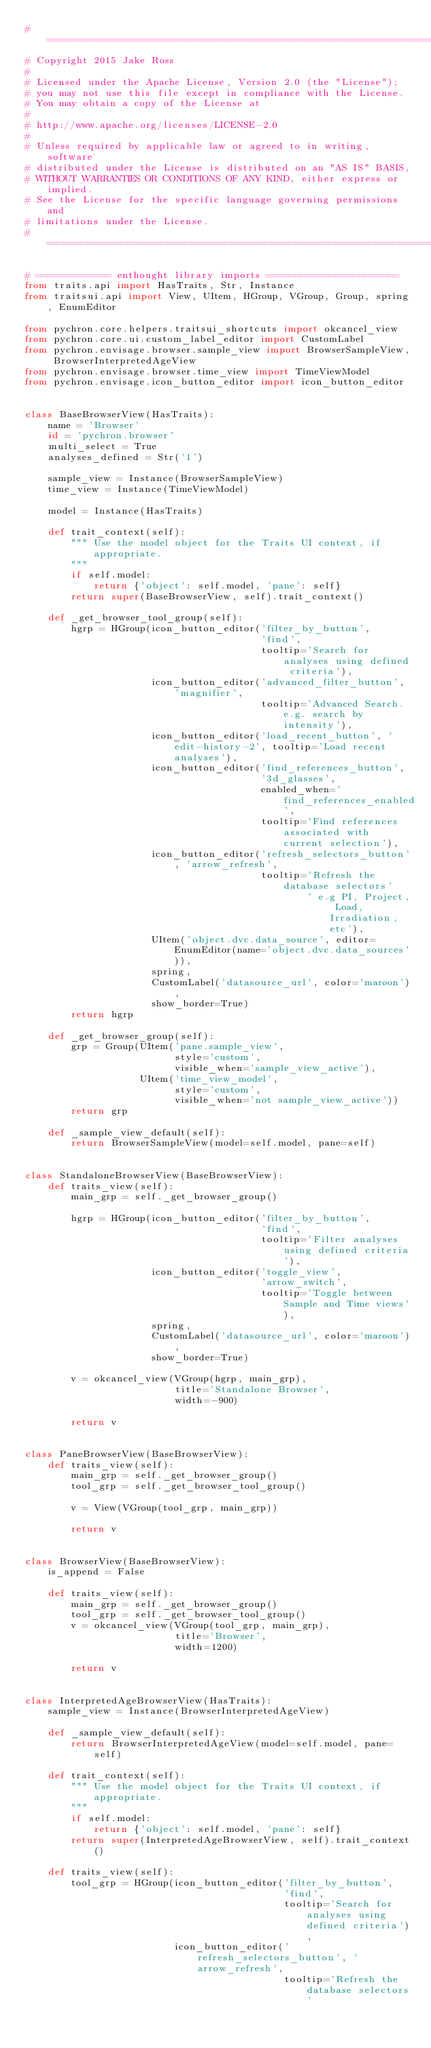<code> <loc_0><loc_0><loc_500><loc_500><_Python_># ===============================================================================
# Copyright 2015 Jake Ross
#
# Licensed under the Apache License, Version 2.0 (the "License");
# you may not use this file except in compliance with the License.
# You may obtain a copy of the License at
#
# http://www.apache.org/licenses/LICENSE-2.0
#
# Unless required by applicable law or agreed to in writing, software
# distributed under the License is distributed on an "AS IS" BASIS,
# WITHOUT WARRANTIES OR CONDITIONS OF ANY KIND, either express or implied.
# See the License for the specific language governing permissions and
# limitations under the License.
# ===============================================================================

# ============= enthought library imports =======================
from traits.api import HasTraits, Str, Instance
from traitsui.api import View, UItem, HGroup, VGroup, Group, spring, EnumEditor

from pychron.core.helpers.traitsui_shortcuts import okcancel_view
from pychron.core.ui.custom_label_editor import CustomLabel
from pychron.envisage.browser.sample_view import BrowserSampleView, BrowserInterpretedAgeView
from pychron.envisage.browser.time_view import TimeViewModel
from pychron.envisage.icon_button_editor import icon_button_editor


class BaseBrowserView(HasTraits):
    name = 'Browser'
    id = 'pychron.browser'
    multi_select = True
    analyses_defined = Str('1')

    sample_view = Instance(BrowserSampleView)
    time_view = Instance(TimeViewModel)

    model = Instance(HasTraits)

    def trait_context(self):
        """ Use the model object for the Traits UI context, if appropriate.
        """
        if self.model:
            return {'object': self.model, 'pane': self}
        return super(BaseBrowserView, self).trait_context()

    def _get_browser_tool_group(self):
        hgrp = HGroup(icon_button_editor('filter_by_button',
                                         'find',
                                         tooltip='Search for analyses using defined criteria'),
                      icon_button_editor('advanced_filter_button', 'magnifier',
                                         tooltip='Advanced Search. e.g. search by intensity'),
                      icon_button_editor('load_recent_button', 'edit-history-2', tooltip='Load recent analyses'),
                      icon_button_editor('find_references_button',
                                         '3d_glasses',
                                         enabled_when='find_references_enabled',
                                         tooltip='Find references associated with current selection'),
                      icon_button_editor('refresh_selectors_button', 'arrow_refresh',
                                         tooltip='Refresh the database selectors'
                                                 ' e.g PI, Project, Load, Irradiation, etc'),
                      UItem('object.dvc.data_source', editor=EnumEditor(name='object.dvc.data_sources')),
                      spring,
                      CustomLabel('datasource_url', color='maroon'),
                      show_border=True)
        return hgrp

    def _get_browser_group(self):
        grp = Group(UItem('pane.sample_view',
                          style='custom',
                          visible_when='sample_view_active'),
                    UItem('time_view_model',
                          style='custom',
                          visible_when='not sample_view_active'))
        return grp

    def _sample_view_default(self):
        return BrowserSampleView(model=self.model, pane=self)


class StandaloneBrowserView(BaseBrowserView):
    def traits_view(self):
        main_grp = self._get_browser_group()

        hgrp = HGroup(icon_button_editor('filter_by_button',
                                         'find',
                                         tooltip='Filter analyses using defined criteria'),
                      icon_button_editor('toggle_view',
                                         'arrow_switch',
                                         tooltip='Toggle between Sample and Time views'),
                      spring,
                      CustomLabel('datasource_url', color='maroon'),
                      show_border=True)

        v = okcancel_view(VGroup(hgrp, main_grp),
                          title='Standalone Browser',
                          width=-900)

        return v


class PaneBrowserView(BaseBrowserView):
    def traits_view(self):
        main_grp = self._get_browser_group()
        tool_grp = self._get_browser_tool_group()

        v = View(VGroup(tool_grp, main_grp))

        return v


class BrowserView(BaseBrowserView):
    is_append = False

    def traits_view(self):
        main_grp = self._get_browser_group()
        tool_grp = self._get_browser_tool_group()
        v = okcancel_view(VGroup(tool_grp, main_grp),
                          title='Browser',
                          width=1200)

        return v


class InterpretedAgeBrowserView(HasTraits):
    sample_view = Instance(BrowserInterpretedAgeView)

    def _sample_view_default(self):
        return BrowserInterpretedAgeView(model=self.model, pane=self)

    def trait_context(self):
        """ Use the model object for the Traits UI context, if appropriate.
        """
        if self.model:
            return {'object': self.model, 'pane': self}
        return super(InterpretedAgeBrowserView, self).trait_context()

    def traits_view(self):
        tool_grp = HGroup(icon_button_editor('filter_by_button',
                                             'find',
                                             tooltip='Search for analyses using defined criteria'),
                          icon_button_editor('refresh_selectors_button', 'arrow_refresh',
                                             tooltip='Refresh the database selectors'</code> 